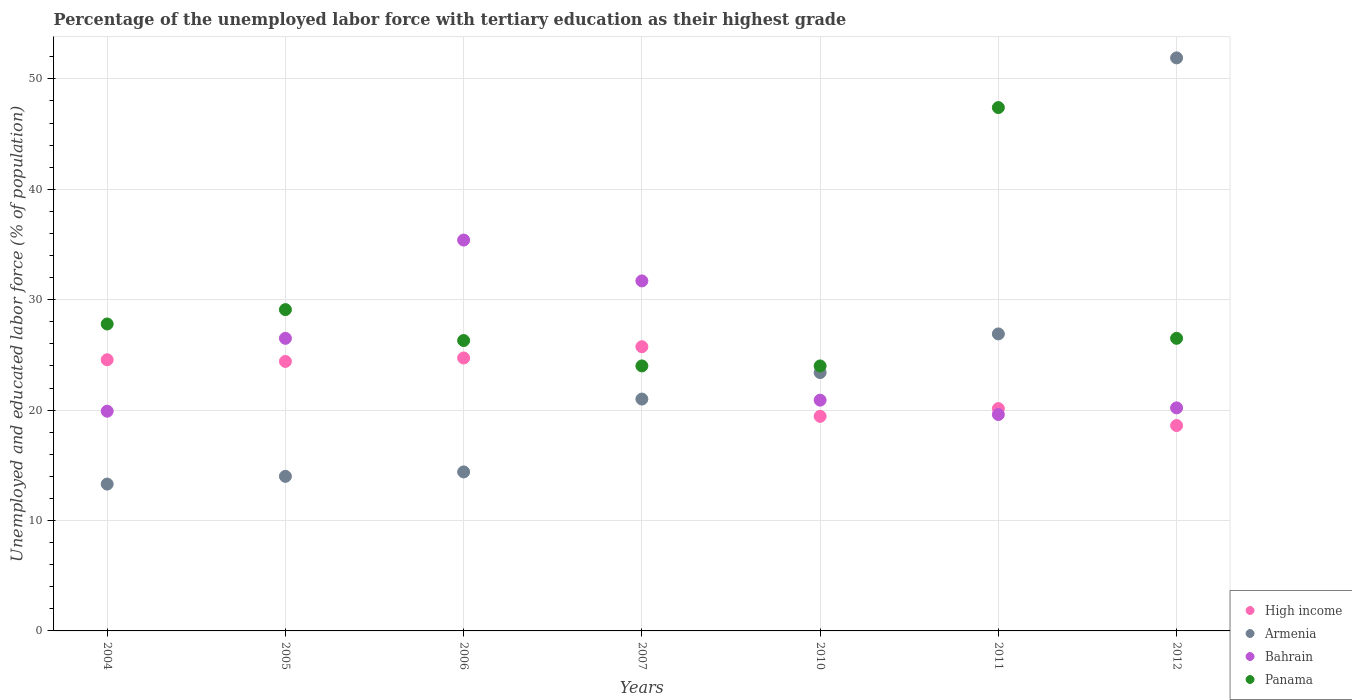How many different coloured dotlines are there?
Provide a succinct answer. 4. What is the percentage of the unemployed labor force with tertiary education in Armenia in 2006?
Keep it short and to the point. 14.4. Across all years, what is the maximum percentage of the unemployed labor force with tertiary education in High income?
Provide a succinct answer. 25.74. Across all years, what is the minimum percentage of the unemployed labor force with tertiary education in Armenia?
Keep it short and to the point. 13.3. In which year was the percentage of the unemployed labor force with tertiary education in High income maximum?
Your response must be concise. 2007. In which year was the percentage of the unemployed labor force with tertiary education in Armenia minimum?
Offer a very short reply. 2004. What is the total percentage of the unemployed labor force with tertiary education in Panama in the graph?
Give a very brief answer. 205.1. What is the difference between the percentage of the unemployed labor force with tertiary education in Armenia in 2004 and that in 2007?
Give a very brief answer. -7.7. What is the difference between the percentage of the unemployed labor force with tertiary education in Armenia in 2007 and the percentage of the unemployed labor force with tertiary education in Panama in 2010?
Give a very brief answer. -3. What is the average percentage of the unemployed labor force with tertiary education in Panama per year?
Offer a very short reply. 29.3. In the year 2005, what is the difference between the percentage of the unemployed labor force with tertiary education in Bahrain and percentage of the unemployed labor force with tertiary education in Panama?
Make the answer very short. -2.6. In how many years, is the percentage of the unemployed labor force with tertiary education in Panama greater than 16 %?
Keep it short and to the point. 7. What is the ratio of the percentage of the unemployed labor force with tertiary education in Panama in 2005 to that in 2012?
Make the answer very short. 1.1. Is the difference between the percentage of the unemployed labor force with tertiary education in Bahrain in 2005 and 2010 greater than the difference between the percentage of the unemployed labor force with tertiary education in Panama in 2005 and 2010?
Make the answer very short. Yes. What is the difference between the highest and the second highest percentage of the unemployed labor force with tertiary education in High income?
Ensure brevity in your answer.  1.02. What is the difference between the highest and the lowest percentage of the unemployed labor force with tertiary education in High income?
Make the answer very short. 7.14. Is the sum of the percentage of the unemployed labor force with tertiary education in High income in 2006 and 2011 greater than the maximum percentage of the unemployed labor force with tertiary education in Armenia across all years?
Your answer should be compact. No. Is it the case that in every year, the sum of the percentage of the unemployed labor force with tertiary education in Panama and percentage of the unemployed labor force with tertiary education in Bahrain  is greater than the percentage of the unemployed labor force with tertiary education in Armenia?
Offer a terse response. No. How many dotlines are there?
Your answer should be very brief. 4. How many years are there in the graph?
Make the answer very short. 7. What is the difference between two consecutive major ticks on the Y-axis?
Provide a succinct answer. 10. Are the values on the major ticks of Y-axis written in scientific E-notation?
Provide a succinct answer. No. Does the graph contain any zero values?
Provide a short and direct response. No. Does the graph contain grids?
Keep it short and to the point. Yes. What is the title of the graph?
Give a very brief answer. Percentage of the unemployed labor force with tertiary education as their highest grade. What is the label or title of the Y-axis?
Your response must be concise. Unemployed and educated labor force (% of population). What is the Unemployed and educated labor force (% of population) of High income in 2004?
Offer a terse response. 24.56. What is the Unemployed and educated labor force (% of population) in Armenia in 2004?
Your response must be concise. 13.3. What is the Unemployed and educated labor force (% of population) in Bahrain in 2004?
Keep it short and to the point. 19.9. What is the Unemployed and educated labor force (% of population) in Panama in 2004?
Your answer should be very brief. 27.8. What is the Unemployed and educated labor force (% of population) in High income in 2005?
Offer a very short reply. 24.41. What is the Unemployed and educated labor force (% of population) of Armenia in 2005?
Your answer should be compact. 14. What is the Unemployed and educated labor force (% of population) in Panama in 2005?
Offer a very short reply. 29.1. What is the Unemployed and educated labor force (% of population) in High income in 2006?
Your response must be concise. 24.72. What is the Unemployed and educated labor force (% of population) of Armenia in 2006?
Make the answer very short. 14.4. What is the Unemployed and educated labor force (% of population) in Bahrain in 2006?
Offer a terse response. 35.4. What is the Unemployed and educated labor force (% of population) of Panama in 2006?
Provide a succinct answer. 26.3. What is the Unemployed and educated labor force (% of population) of High income in 2007?
Offer a very short reply. 25.74. What is the Unemployed and educated labor force (% of population) of Bahrain in 2007?
Your answer should be very brief. 31.7. What is the Unemployed and educated labor force (% of population) in Panama in 2007?
Give a very brief answer. 24. What is the Unemployed and educated labor force (% of population) of High income in 2010?
Give a very brief answer. 19.44. What is the Unemployed and educated labor force (% of population) in Armenia in 2010?
Your answer should be very brief. 23.4. What is the Unemployed and educated labor force (% of population) in Bahrain in 2010?
Ensure brevity in your answer.  20.9. What is the Unemployed and educated labor force (% of population) in Panama in 2010?
Provide a short and direct response. 24. What is the Unemployed and educated labor force (% of population) in High income in 2011?
Provide a short and direct response. 20.14. What is the Unemployed and educated labor force (% of population) of Armenia in 2011?
Your answer should be compact. 26.9. What is the Unemployed and educated labor force (% of population) of Bahrain in 2011?
Keep it short and to the point. 19.6. What is the Unemployed and educated labor force (% of population) in Panama in 2011?
Give a very brief answer. 47.4. What is the Unemployed and educated labor force (% of population) of High income in 2012?
Keep it short and to the point. 18.6. What is the Unemployed and educated labor force (% of population) of Armenia in 2012?
Offer a very short reply. 51.9. What is the Unemployed and educated labor force (% of population) in Bahrain in 2012?
Your answer should be compact. 20.2. Across all years, what is the maximum Unemployed and educated labor force (% of population) in High income?
Offer a very short reply. 25.74. Across all years, what is the maximum Unemployed and educated labor force (% of population) of Armenia?
Keep it short and to the point. 51.9. Across all years, what is the maximum Unemployed and educated labor force (% of population) in Bahrain?
Your response must be concise. 35.4. Across all years, what is the maximum Unemployed and educated labor force (% of population) in Panama?
Offer a very short reply. 47.4. Across all years, what is the minimum Unemployed and educated labor force (% of population) of High income?
Provide a short and direct response. 18.6. Across all years, what is the minimum Unemployed and educated labor force (% of population) in Armenia?
Ensure brevity in your answer.  13.3. Across all years, what is the minimum Unemployed and educated labor force (% of population) of Bahrain?
Provide a succinct answer. 19.6. Across all years, what is the minimum Unemployed and educated labor force (% of population) in Panama?
Provide a short and direct response. 24. What is the total Unemployed and educated labor force (% of population) of High income in the graph?
Offer a terse response. 157.6. What is the total Unemployed and educated labor force (% of population) in Armenia in the graph?
Provide a short and direct response. 164.9. What is the total Unemployed and educated labor force (% of population) of Bahrain in the graph?
Your answer should be compact. 174.2. What is the total Unemployed and educated labor force (% of population) of Panama in the graph?
Offer a very short reply. 205.1. What is the difference between the Unemployed and educated labor force (% of population) in High income in 2004 and that in 2005?
Keep it short and to the point. 0.15. What is the difference between the Unemployed and educated labor force (% of population) in High income in 2004 and that in 2006?
Keep it short and to the point. -0.16. What is the difference between the Unemployed and educated labor force (% of population) in Bahrain in 2004 and that in 2006?
Make the answer very short. -15.5. What is the difference between the Unemployed and educated labor force (% of population) in High income in 2004 and that in 2007?
Provide a succinct answer. -1.18. What is the difference between the Unemployed and educated labor force (% of population) of Armenia in 2004 and that in 2007?
Offer a terse response. -7.7. What is the difference between the Unemployed and educated labor force (% of population) in Bahrain in 2004 and that in 2007?
Ensure brevity in your answer.  -11.8. What is the difference between the Unemployed and educated labor force (% of population) of High income in 2004 and that in 2010?
Your response must be concise. 5.12. What is the difference between the Unemployed and educated labor force (% of population) in Armenia in 2004 and that in 2010?
Your response must be concise. -10.1. What is the difference between the Unemployed and educated labor force (% of population) in Bahrain in 2004 and that in 2010?
Your answer should be compact. -1. What is the difference between the Unemployed and educated labor force (% of population) of High income in 2004 and that in 2011?
Provide a short and direct response. 4.42. What is the difference between the Unemployed and educated labor force (% of population) in Armenia in 2004 and that in 2011?
Offer a very short reply. -13.6. What is the difference between the Unemployed and educated labor force (% of population) of Panama in 2004 and that in 2011?
Your answer should be compact. -19.6. What is the difference between the Unemployed and educated labor force (% of population) in High income in 2004 and that in 2012?
Offer a terse response. 5.96. What is the difference between the Unemployed and educated labor force (% of population) in Armenia in 2004 and that in 2012?
Make the answer very short. -38.6. What is the difference between the Unemployed and educated labor force (% of population) of Bahrain in 2004 and that in 2012?
Your answer should be compact. -0.3. What is the difference between the Unemployed and educated labor force (% of population) of High income in 2005 and that in 2006?
Ensure brevity in your answer.  -0.31. What is the difference between the Unemployed and educated labor force (% of population) of Armenia in 2005 and that in 2006?
Provide a short and direct response. -0.4. What is the difference between the Unemployed and educated labor force (% of population) in Bahrain in 2005 and that in 2006?
Offer a terse response. -8.9. What is the difference between the Unemployed and educated labor force (% of population) of Panama in 2005 and that in 2006?
Give a very brief answer. 2.8. What is the difference between the Unemployed and educated labor force (% of population) of High income in 2005 and that in 2007?
Offer a very short reply. -1.33. What is the difference between the Unemployed and educated labor force (% of population) of Armenia in 2005 and that in 2007?
Ensure brevity in your answer.  -7. What is the difference between the Unemployed and educated labor force (% of population) of High income in 2005 and that in 2010?
Keep it short and to the point. 4.97. What is the difference between the Unemployed and educated labor force (% of population) in Armenia in 2005 and that in 2010?
Give a very brief answer. -9.4. What is the difference between the Unemployed and educated labor force (% of population) in High income in 2005 and that in 2011?
Keep it short and to the point. 4.27. What is the difference between the Unemployed and educated labor force (% of population) of Armenia in 2005 and that in 2011?
Ensure brevity in your answer.  -12.9. What is the difference between the Unemployed and educated labor force (% of population) in Bahrain in 2005 and that in 2011?
Ensure brevity in your answer.  6.9. What is the difference between the Unemployed and educated labor force (% of population) in Panama in 2005 and that in 2011?
Ensure brevity in your answer.  -18.3. What is the difference between the Unemployed and educated labor force (% of population) of High income in 2005 and that in 2012?
Offer a terse response. 5.81. What is the difference between the Unemployed and educated labor force (% of population) of Armenia in 2005 and that in 2012?
Give a very brief answer. -37.9. What is the difference between the Unemployed and educated labor force (% of population) of Panama in 2005 and that in 2012?
Make the answer very short. 2.6. What is the difference between the Unemployed and educated labor force (% of population) in High income in 2006 and that in 2007?
Ensure brevity in your answer.  -1.02. What is the difference between the Unemployed and educated labor force (% of population) in Armenia in 2006 and that in 2007?
Offer a very short reply. -6.6. What is the difference between the Unemployed and educated labor force (% of population) of Bahrain in 2006 and that in 2007?
Provide a short and direct response. 3.7. What is the difference between the Unemployed and educated labor force (% of population) in Panama in 2006 and that in 2007?
Give a very brief answer. 2.3. What is the difference between the Unemployed and educated labor force (% of population) of High income in 2006 and that in 2010?
Provide a short and direct response. 5.29. What is the difference between the Unemployed and educated labor force (% of population) in Armenia in 2006 and that in 2010?
Give a very brief answer. -9. What is the difference between the Unemployed and educated labor force (% of population) in Panama in 2006 and that in 2010?
Your response must be concise. 2.3. What is the difference between the Unemployed and educated labor force (% of population) of High income in 2006 and that in 2011?
Offer a terse response. 4.58. What is the difference between the Unemployed and educated labor force (% of population) of Armenia in 2006 and that in 2011?
Your answer should be very brief. -12.5. What is the difference between the Unemployed and educated labor force (% of population) in Panama in 2006 and that in 2011?
Provide a short and direct response. -21.1. What is the difference between the Unemployed and educated labor force (% of population) of High income in 2006 and that in 2012?
Offer a terse response. 6.12. What is the difference between the Unemployed and educated labor force (% of population) in Armenia in 2006 and that in 2012?
Your answer should be compact. -37.5. What is the difference between the Unemployed and educated labor force (% of population) in High income in 2007 and that in 2010?
Your answer should be compact. 6.3. What is the difference between the Unemployed and educated labor force (% of population) in Armenia in 2007 and that in 2010?
Your answer should be very brief. -2.4. What is the difference between the Unemployed and educated labor force (% of population) in Bahrain in 2007 and that in 2010?
Your response must be concise. 10.8. What is the difference between the Unemployed and educated labor force (% of population) of Panama in 2007 and that in 2010?
Offer a very short reply. 0. What is the difference between the Unemployed and educated labor force (% of population) in High income in 2007 and that in 2011?
Make the answer very short. 5.6. What is the difference between the Unemployed and educated labor force (% of population) of Panama in 2007 and that in 2011?
Offer a terse response. -23.4. What is the difference between the Unemployed and educated labor force (% of population) of High income in 2007 and that in 2012?
Give a very brief answer. 7.14. What is the difference between the Unemployed and educated labor force (% of population) in Armenia in 2007 and that in 2012?
Your answer should be very brief. -30.9. What is the difference between the Unemployed and educated labor force (% of population) of High income in 2010 and that in 2011?
Ensure brevity in your answer.  -0.7. What is the difference between the Unemployed and educated labor force (% of population) of Armenia in 2010 and that in 2011?
Your response must be concise. -3.5. What is the difference between the Unemployed and educated labor force (% of population) in Panama in 2010 and that in 2011?
Your response must be concise. -23.4. What is the difference between the Unemployed and educated labor force (% of population) of High income in 2010 and that in 2012?
Your response must be concise. 0.83. What is the difference between the Unemployed and educated labor force (% of population) in Armenia in 2010 and that in 2012?
Offer a very short reply. -28.5. What is the difference between the Unemployed and educated labor force (% of population) in Panama in 2010 and that in 2012?
Your response must be concise. -2.5. What is the difference between the Unemployed and educated labor force (% of population) in High income in 2011 and that in 2012?
Your response must be concise. 1.54. What is the difference between the Unemployed and educated labor force (% of population) in Armenia in 2011 and that in 2012?
Make the answer very short. -25. What is the difference between the Unemployed and educated labor force (% of population) in Bahrain in 2011 and that in 2012?
Your response must be concise. -0.6. What is the difference between the Unemployed and educated labor force (% of population) of Panama in 2011 and that in 2012?
Offer a very short reply. 20.9. What is the difference between the Unemployed and educated labor force (% of population) in High income in 2004 and the Unemployed and educated labor force (% of population) in Armenia in 2005?
Offer a terse response. 10.56. What is the difference between the Unemployed and educated labor force (% of population) in High income in 2004 and the Unemployed and educated labor force (% of population) in Bahrain in 2005?
Your response must be concise. -1.94. What is the difference between the Unemployed and educated labor force (% of population) of High income in 2004 and the Unemployed and educated labor force (% of population) of Panama in 2005?
Make the answer very short. -4.54. What is the difference between the Unemployed and educated labor force (% of population) of Armenia in 2004 and the Unemployed and educated labor force (% of population) of Panama in 2005?
Provide a short and direct response. -15.8. What is the difference between the Unemployed and educated labor force (% of population) of High income in 2004 and the Unemployed and educated labor force (% of population) of Armenia in 2006?
Ensure brevity in your answer.  10.16. What is the difference between the Unemployed and educated labor force (% of population) in High income in 2004 and the Unemployed and educated labor force (% of population) in Bahrain in 2006?
Ensure brevity in your answer.  -10.84. What is the difference between the Unemployed and educated labor force (% of population) of High income in 2004 and the Unemployed and educated labor force (% of population) of Panama in 2006?
Your response must be concise. -1.74. What is the difference between the Unemployed and educated labor force (% of population) in Armenia in 2004 and the Unemployed and educated labor force (% of population) in Bahrain in 2006?
Provide a short and direct response. -22.1. What is the difference between the Unemployed and educated labor force (% of population) in Armenia in 2004 and the Unemployed and educated labor force (% of population) in Panama in 2006?
Offer a terse response. -13. What is the difference between the Unemployed and educated labor force (% of population) in High income in 2004 and the Unemployed and educated labor force (% of population) in Armenia in 2007?
Your answer should be very brief. 3.56. What is the difference between the Unemployed and educated labor force (% of population) of High income in 2004 and the Unemployed and educated labor force (% of population) of Bahrain in 2007?
Offer a terse response. -7.14. What is the difference between the Unemployed and educated labor force (% of population) in High income in 2004 and the Unemployed and educated labor force (% of population) in Panama in 2007?
Give a very brief answer. 0.56. What is the difference between the Unemployed and educated labor force (% of population) in Armenia in 2004 and the Unemployed and educated labor force (% of population) in Bahrain in 2007?
Your answer should be compact. -18.4. What is the difference between the Unemployed and educated labor force (% of population) in Armenia in 2004 and the Unemployed and educated labor force (% of population) in Panama in 2007?
Make the answer very short. -10.7. What is the difference between the Unemployed and educated labor force (% of population) in Bahrain in 2004 and the Unemployed and educated labor force (% of population) in Panama in 2007?
Provide a short and direct response. -4.1. What is the difference between the Unemployed and educated labor force (% of population) of High income in 2004 and the Unemployed and educated labor force (% of population) of Armenia in 2010?
Your response must be concise. 1.16. What is the difference between the Unemployed and educated labor force (% of population) of High income in 2004 and the Unemployed and educated labor force (% of population) of Bahrain in 2010?
Give a very brief answer. 3.66. What is the difference between the Unemployed and educated labor force (% of population) of High income in 2004 and the Unemployed and educated labor force (% of population) of Panama in 2010?
Provide a succinct answer. 0.56. What is the difference between the Unemployed and educated labor force (% of population) in Armenia in 2004 and the Unemployed and educated labor force (% of population) in Bahrain in 2010?
Offer a very short reply. -7.6. What is the difference between the Unemployed and educated labor force (% of population) of Armenia in 2004 and the Unemployed and educated labor force (% of population) of Panama in 2010?
Your response must be concise. -10.7. What is the difference between the Unemployed and educated labor force (% of population) in Bahrain in 2004 and the Unemployed and educated labor force (% of population) in Panama in 2010?
Your answer should be very brief. -4.1. What is the difference between the Unemployed and educated labor force (% of population) in High income in 2004 and the Unemployed and educated labor force (% of population) in Armenia in 2011?
Ensure brevity in your answer.  -2.34. What is the difference between the Unemployed and educated labor force (% of population) of High income in 2004 and the Unemployed and educated labor force (% of population) of Bahrain in 2011?
Your response must be concise. 4.96. What is the difference between the Unemployed and educated labor force (% of population) in High income in 2004 and the Unemployed and educated labor force (% of population) in Panama in 2011?
Your answer should be very brief. -22.84. What is the difference between the Unemployed and educated labor force (% of population) in Armenia in 2004 and the Unemployed and educated labor force (% of population) in Bahrain in 2011?
Your response must be concise. -6.3. What is the difference between the Unemployed and educated labor force (% of population) of Armenia in 2004 and the Unemployed and educated labor force (% of population) of Panama in 2011?
Make the answer very short. -34.1. What is the difference between the Unemployed and educated labor force (% of population) in Bahrain in 2004 and the Unemployed and educated labor force (% of population) in Panama in 2011?
Keep it short and to the point. -27.5. What is the difference between the Unemployed and educated labor force (% of population) in High income in 2004 and the Unemployed and educated labor force (% of population) in Armenia in 2012?
Make the answer very short. -27.34. What is the difference between the Unemployed and educated labor force (% of population) of High income in 2004 and the Unemployed and educated labor force (% of population) of Bahrain in 2012?
Keep it short and to the point. 4.36. What is the difference between the Unemployed and educated labor force (% of population) in High income in 2004 and the Unemployed and educated labor force (% of population) in Panama in 2012?
Give a very brief answer. -1.94. What is the difference between the Unemployed and educated labor force (% of population) of High income in 2005 and the Unemployed and educated labor force (% of population) of Armenia in 2006?
Offer a very short reply. 10.01. What is the difference between the Unemployed and educated labor force (% of population) in High income in 2005 and the Unemployed and educated labor force (% of population) in Bahrain in 2006?
Provide a short and direct response. -10.99. What is the difference between the Unemployed and educated labor force (% of population) in High income in 2005 and the Unemployed and educated labor force (% of population) in Panama in 2006?
Keep it short and to the point. -1.89. What is the difference between the Unemployed and educated labor force (% of population) of Armenia in 2005 and the Unemployed and educated labor force (% of population) of Bahrain in 2006?
Offer a terse response. -21.4. What is the difference between the Unemployed and educated labor force (% of population) in Armenia in 2005 and the Unemployed and educated labor force (% of population) in Panama in 2006?
Offer a very short reply. -12.3. What is the difference between the Unemployed and educated labor force (% of population) in Bahrain in 2005 and the Unemployed and educated labor force (% of population) in Panama in 2006?
Your answer should be very brief. 0.2. What is the difference between the Unemployed and educated labor force (% of population) in High income in 2005 and the Unemployed and educated labor force (% of population) in Armenia in 2007?
Make the answer very short. 3.41. What is the difference between the Unemployed and educated labor force (% of population) of High income in 2005 and the Unemployed and educated labor force (% of population) of Bahrain in 2007?
Provide a succinct answer. -7.29. What is the difference between the Unemployed and educated labor force (% of population) of High income in 2005 and the Unemployed and educated labor force (% of population) of Panama in 2007?
Your response must be concise. 0.41. What is the difference between the Unemployed and educated labor force (% of population) in Armenia in 2005 and the Unemployed and educated labor force (% of population) in Bahrain in 2007?
Provide a succinct answer. -17.7. What is the difference between the Unemployed and educated labor force (% of population) in High income in 2005 and the Unemployed and educated labor force (% of population) in Armenia in 2010?
Make the answer very short. 1.01. What is the difference between the Unemployed and educated labor force (% of population) in High income in 2005 and the Unemployed and educated labor force (% of population) in Bahrain in 2010?
Provide a succinct answer. 3.51. What is the difference between the Unemployed and educated labor force (% of population) in High income in 2005 and the Unemployed and educated labor force (% of population) in Panama in 2010?
Keep it short and to the point. 0.41. What is the difference between the Unemployed and educated labor force (% of population) in Armenia in 2005 and the Unemployed and educated labor force (% of population) in Bahrain in 2010?
Give a very brief answer. -6.9. What is the difference between the Unemployed and educated labor force (% of population) in Armenia in 2005 and the Unemployed and educated labor force (% of population) in Panama in 2010?
Offer a very short reply. -10. What is the difference between the Unemployed and educated labor force (% of population) in High income in 2005 and the Unemployed and educated labor force (% of population) in Armenia in 2011?
Keep it short and to the point. -2.49. What is the difference between the Unemployed and educated labor force (% of population) of High income in 2005 and the Unemployed and educated labor force (% of population) of Bahrain in 2011?
Offer a terse response. 4.81. What is the difference between the Unemployed and educated labor force (% of population) in High income in 2005 and the Unemployed and educated labor force (% of population) in Panama in 2011?
Keep it short and to the point. -22.99. What is the difference between the Unemployed and educated labor force (% of population) in Armenia in 2005 and the Unemployed and educated labor force (% of population) in Bahrain in 2011?
Provide a short and direct response. -5.6. What is the difference between the Unemployed and educated labor force (% of population) of Armenia in 2005 and the Unemployed and educated labor force (% of population) of Panama in 2011?
Give a very brief answer. -33.4. What is the difference between the Unemployed and educated labor force (% of population) in Bahrain in 2005 and the Unemployed and educated labor force (% of population) in Panama in 2011?
Provide a succinct answer. -20.9. What is the difference between the Unemployed and educated labor force (% of population) of High income in 2005 and the Unemployed and educated labor force (% of population) of Armenia in 2012?
Keep it short and to the point. -27.49. What is the difference between the Unemployed and educated labor force (% of population) in High income in 2005 and the Unemployed and educated labor force (% of population) in Bahrain in 2012?
Make the answer very short. 4.21. What is the difference between the Unemployed and educated labor force (% of population) in High income in 2005 and the Unemployed and educated labor force (% of population) in Panama in 2012?
Make the answer very short. -2.09. What is the difference between the Unemployed and educated labor force (% of population) of High income in 2006 and the Unemployed and educated labor force (% of population) of Armenia in 2007?
Keep it short and to the point. 3.72. What is the difference between the Unemployed and educated labor force (% of population) of High income in 2006 and the Unemployed and educated labor force (% of population) of Bahrain in 2007?
Offer a terse response. -6.98. What is the difference between the Unemployed and educated labor force (% of population) of High income in 2006 and the Unemployed and educated labor force (% of population) of Panama in 2007?
Give a very brief answer. 0.72. What is the difference between the Unemployed and educated labor force (% of population) in Armenia in 2006 and the Unemployed and educated labor force (% of population) in Bahrain in 2007?
Make the answer very short. -17.3. What is the difference between the Unemployed and educated labor force (% of population) of Armenia in 2006 and the Unemployed and educated labor force (% of population) of Panama in 2007?
Keep it short and to the point. -9.6. What is the difference between the Unemployed and educated labor force (% of population) in Bahrain in 2006 and the Unemployed and educated labor force (% of population) in Panama in 2007?
Your answer should be compact. 11.4. What is the difference between the Unemployed and educated labor force (% of population) in High income in 2006 and the Unemployed and educated labor force (% of population) in Armenia in 2010?
Ensure brevity in your answer.  1.32. What is the difference between the Unemployed and educated labor force (% of population) in High income in 2006 and the Unemployed and educated labor force (% of population) in Bahrain in 2010?
Your answer should be compact. 3.82. What is the difference between the Unemployed and educated labor force (% of population) of High income in 2006 and the Unemployed and educated labor force (% of population) of Panama in 2010?
Offer a very short reply. 0.72. What is the difference between the Unemployed and educated labor force (% of population) of Armenia in 2006 and the Unemployed and educated labor force (% of population) of Bahrain in 2010?
Provide a succinct answer. -6.5. What is the difference between the Unemployed and educated labor force (% of population) in High income in 2006 and the Unemployed and educated labor force (% of population) in Armenia in 2011?
Provide a short and direct response. -2.18. What is the difference between the Unemployed and educated labor force (% of population) in High income in 2006 and the Unemployed and educated labor force (% of population) in Bahrain in 2011?
Provide a succinct answer. 5.12. What is the difference between the Unemployed and educated labor force (% of population) of High income in 2006 and the Unemployed and educated labor force (% of population) of Panama in 2011?
Your response must be concise. -22.68. What is the difference between the Unemployed and educated labor force (% of population) of Armenia in 2006 and the Unemployed and educated labor force (% of population) of Panama in 2011?
Give a very brief answer. -33. What is the difference between the Unemployed and educated labor force (% of population) in Bahrain in 2006 and the Unemployed and educated labor force (% of population) in Panama in 2011?
Provide a short and direct response. -12. What is the difference between the Unemployed and educated labor force (% of population) of High income in 2006 and the Unemployed and educated labor force (% of population) of Armenia in 2012?
Your response must be concise. -27.18. What is the difference between the Unemployed and educated labor force (% of population) of High income in 2006 and the Unemployed and educated labor force (% of population) of Bahrain in 2012?
Ensure brevity in your answer.  4.52. What is the difference between the Unemployed and educated labor force (% of population) of High income in 2006 and the Unemployed and educated labor force (% of population) of Panama in 2012?
Your answer should be very brief. -1.78. What is the difference between the Unemployed and educated labor force (% of population) of Armenia in 2006 and the Unemployed and educated labor force (% of population) of Bahrain in 2012?
Provide a succinct answer. -5.8. What is the difference between the Unemployed and educated labor force (% of population) of High income in 2007 and the Unemployed and educated labor force (% of population) of Armenia in 2010?
Make the answer very short. 2.34. What is the difference between the Unemployed and educated labor force (% of population) of High income in 2007 and the Unemployed and educated labor force (% of population) of Bahrain in 2010?
Give a very brief answer. 4.84. What is the difference between the Unemployed and educated labor force (% of population) in High income in 2007 and the Unemployed and educated labor force (% of population) in Panama in 2010?
Offer a very short reply. 1.74. What is the difference between the Unemployed and educated labor force (% of population) of Armenia in 2007 and the Unemployed and educated labor force (% of population) of Panama in 2010?
Your response must be concise. -3. What is the difference between the Unemployed and educated labor force (% of population) in High income in 2007 and the Unemployed and educated labor force (% of population) in Armenia in 2011?
Your answer should be compact. -1.16. What is the difference between the Unemployed and educated labor force (% of population) of High income in 2007 and the Unemployed and educated labor force (% of population) of Bahrain in 2011?
Offer a terse response. 6.14. What is the difference between the Unemployed and educated labor force (% of population) of High income in 2007 and the Unemployed and educated labor force (% of population) of Panama in 2011?
Give a very brief answer. -21.66. What is the difference between the Unemployed and educated labor force (% of population) in Armenia in 2007 and the Unemployed and educated labor force (% of population) in Bahrain in 2011?
Ensure brevity in your answer.  1.4. What is the difference between the Unemployed and educated labor force (% of population) in Armenia in 2007 and the Unemployed and educated labor force (% of population) in Panama in 2011?
Provide a succinct answer. -26.4. What is the difference between the Unemployed and educated labor force (% of population) in Bahrain in 2007 and the Unemployed and educated labor force (% of population) in Panama in 2011?
Your response must be concise. -15.7. What is the difference between the Unemployed and educated labor force (% of population) of High income in 2007 and the Unemployed and educated labor force (% of population) of Armenia in 2012?
Offer a terse response. -26.16. What is the difference between the Unemployed and educated labor force (% of population) in High income in 2007 and the Unemployed and educated labor force (% of population) in Bahrain in 2012?
Keep it short and to the point. 5.54. What is the difference between the Unemployed and educated labor force (% of population) of High income in 2007 and the Unemployed and educated labor force (% of population) of Panama in 2012?
Keep it short and to the point. -0.76. What is the difference between the Unemployed and educated labor force (% of population) in Armenia in 2007 and the Unemployed and educated labor force (% of population) in Panama in 2012?
Give a very brief answer. -5.5. What is the difference between the Unemployed and educated labor force (% of population) in Bahrain in 2007 and the Unemployed and educated labor force (% of population) in Panama in 2012?
Give a very brief answer. 5.2. What is the difference between the Unemployed and educated labor force (% of population) of High income in 2010 and the Unemployed and educated labor force (% of population) of Armenia in 2011?
Offer a terse response. -7.46. What is the difference between the Unemployed and educated labor force (% of population) in High income in 2010 and the Unemployed and educated labor force (% of population) in Bahrain in 2011?
Offer a very short reply. -0.16. What is the difference between the Unemployed and educated labor force (% of population) in High income in 2010 and the Unemployed and educated labor force (% of population) in Panama in 2011?
Your answer should be very brief. -27.96. What is the difference between the Unemployed and educated labor force (% of population) in Armenia in 2010 and the Unemployed and educated labor force (% of population) in Panama in 2011?
Your response must be concise. -24. What is the difference between the Unemployed and educated labor force (% of population) in Bahrain in 2010 and the Unemployed and educated labor force (% of population) in Panama in 2011?
Your answer should be compact. -26.5. What is the difference between the Unemployed and educated labor force (% of population) in High income in 2010 and the Unemployed and educated labor force (% of population) in Armenia in 2012?
Offer a terse response. -32.46. What is the difference between the Unemployed and educated labor force (% of population) of High income in 2010 and the Unemployed and educated labor force (% of population) of Bahrain in 2012?
Your response must be concise. -0.76. What is the difference between the Unemployed and educated labor force (% of population) of High income in 2010 and the Unemployed and educated labor force (% of population) of Panama in 2012?
Offer a terse response. -7.06. What is the difference between the Unemployed and educated labor force (% of population) in Armenia in 2010 and the Unemployed and educated labor force (% of population) in Bahrain in 2012?
Your response must be concise. 3.2. What is the difference between the Unemployed and educated labor force (% of population) of Armenia in 2010 and the Unemployed and educated labor force (% of population) of Panama in 2012?
Ensure brevity in your answer.  -3.1. What is the difference between the Unemployed and educated labor force (% of population) of High income in 2011 and the Unemployed and educated labor force (% of population) of Armenia in 2012?
Offer a terse response. -31.76. What is the difference between the Unemployed and educated labor force (% of population) in High income in 2011 and the Unemployed and educated labor force (% of population) in Bahrain in 2012?
Offer a terse response. -0.06. What is the difference between the Unemployed and educated labor force (% of population) of High income in 2011 and the Unemployed and educated labor force (% of population) of Panama in 2012?
Keep it short and to the point. -6.36. What is the difference between the Unemployed and educated labor force (% of population) of Armenia in 2011 and the Unemployed and educated labor force (% of population) of Panama in 2012?
Your answer should be compact. 0.4. What is the difference between the Unemployed and educated labor force (% of population) in Bahrain in 2011 and the Unemployed and educated labor force (% of population) in Panama in 2012?
Make the answer very short. -6.9. What is the average Unemployed and educated labor force (% of population) of High income per year?
Offer a very short reply. 22.51. What is the average Unemployed and educated labor force (% of population) in Armenia per year?
Make the answer very short. 23.56. What is the average Unemployed and educated labor force (% of population) in Bahrain per year?
Ensure brevity in your answer.  24.89. What is the average Unemployed and educated labor force (% of population) in Panama per year?
Your answer should be very brief. 29.3. In the year 2004, what is the difference between the Unemployed and educated labor force (% of population) in High income and Unemployed and educated labor force (% of population) in Armenia?
Provide a succinct answer. 11.26. In the year 2004, what is the difference between the Unemployed and educated labor force (% of population) of High income and Unemployed and educated labor force (% of population) of Bahrain?
Give a very brief answer. 4.66. In the year 2004, what is the difference between the Unemployed and educated labor force (% of population) in High income and Unemployed and educated labor force (% of population) in Panama?
Ensure brevity in your answer.  -3.24. In the year 2004, what is the difference between the Unemployed and educated labor force (% of population) of Armenia and Unemployed and educated labor force (% of population) of Bahrain?
Give a very brief answer. -6.6. In the year 2004, what is the difference between the Unemployed and educated labor force (% of population) in Bahrain and Unemployed and educated labor force (% of population) in Panama?
Your answer should be very brief. -7.9. In the year 2005, what is the difference between the Unemployed and educated labor force (% of population) of High income and Unemployed and educated labor force (% of population) of Armenia?
Your response must be concise. 10.41. In the year 2005, what is the difference between the Unemployed and educated labor force (% of population) in High income and Unemployed and educated labor force (% of population) in Bahrain?
Give a very brief answer. -2.09. In the year 2005, what is the difference between the Unemployed and educated labor force (% of population) of High income and Unemployed and educated labor force (% of population) of Panama?
Give a very brief answer. -4.69. In the year 2005, what is the difference between the Unemployed and educated labor force (% of population) of Armenia and Unemployed and educated labor force (% of population) of Bahrain?
Your answer should be compact. -12.5. In the year 2005, what is the difference between the Unemployed and educated labor force (% of population) in Armenia and Unemployed and educated labor force (% of population) in Panama?
Offer a terse response. -15.1. In the year 2005, what is the difference between the Unemployed and educated labor force (% of population) of Bahrain and Unemployed and educated labor force (% of population) of Panama?
Make the answer very short. -2.6. In the year 2006, what is the difference between the Unemployed and educated labor force (% of population) of High income and Unemployed and educated labor force (% of population) of Armenia?
Provide a succinct answer. 10.32. In the year 2006, what is the difference between the Unemployed and educated labor force (% of population) in High income and Unemployed and educated labor force (% of population) in Bahrain?
Give a very brief answer. -10.68. In the year 2006, what is the difference between the Unemployed and educated labor force (% of population) in High income and Unemployed and educated labor force (% of population) in Panama?
Offer a very short reply. -1.58. In the year 2006, what is the difference between the Unemployed and educated labor force (% of population) of Armenia and Unemployed and educated labor force (% of population) of Panama?
Your response must be concise. -11.9. In the year 2006, what is the difference between the Unemployed and educated labor force (% of population) in Bahrain and Unemployed and educated labor force (% of population) in Panama?
Your answer should be very brief. 9.1. In the year 2007, what is the difference between the Unemployed and educated labor force (% of population) of High income and Unemployed and educated labor force (% of population) of Armenia?
Provide a short and direct response. 4.74. In the year 2007, what is the difference between the Unemployed and educated labor force (% of population) in High income and Unemployed and educated labor force (% of population) in Bahrain?
Keep it short and to the point. -5.96. In the year 2007, what is the difference between the Unemployed and educated labor force (% of population) in High income and Unemployed and educated labor force (% of population) in Panama?
Ensure brevity in your answer.  1.74. In the year 2007, what is the difference between the Unemployed and educated labor force (% of population) in Armenia and Unemployed and educated labor force (% of population) in Panama?
Your answer should be very brief. -3. In the year 2007, what is the difference between the Unemployed and educated labor force (% of population) of Bahrain and Unemployed and educated labor force (% of population) of Panama?
Offer a very short reply. 7.7. In the year 2010, what is the difference between the Unemployed and educated labor force (% of population) of High income and Unemployed and educated labor force (% of population) of Armenia?
Offer a very short reply. -3.96. In the year 2010, what is the difference between the Unemployed and educated labor force (% of population) in High income and Unemployed and educated labor force (% of population) in Bahrain?
Your answer should be compact. -1.46. In the year 2010, what is the difference between the Unemployed and educated labor force (% of population) in High income and Unemployed and educated labor force (% of population) in Panama?
Your answer should be compact. -4.56. In the year 2010, what is the difference between the Unemployed and educated labor force (% of population) of Armenia and Unemployed and educated labor force (% of population) of Bahrain?
Make the answer very short. 2.5. In the year 2011, what is the difference between the Unemployed and educated labor force (% of population) in High income and Unemployed and educated labor force (% of population) in Armenia?
Your response must be concise. -6.76. In the year 2011, what is the difference between the Unemployed and educated labor force (% of population) in High income and Unemployed and educated labor force (% of population) in Bahrain?
Provide a succinct answer. 0.54. In the year 2011, what is the difference between the Unemployed and educated labor force (% of population) of High income and Unemployed and educated labor force (% of population) of Panama?
Ensure brevity in your answer.  -27.26. In the year 2011, what is the difference between the Unemployed and educated labor force (% of population) in Armenia and Unemployed and educated labor force (% of population) in Bahrain?
Your answer should be very brief. 7.3. In the year 2011, what is the difference between the Unemployed and educated labor force (% of population) in Armenia and Unemployed and educated labor force (% of population) in Panama?
Your answer should be compact. -20.5. In the year 2011, what is the difference between the Unemployed and educated labor force (% of population) in Bahrain and Unemployed and educated labor force (% of population) in Panama?
Offer a terse response. -27.8. In the year 2012, what is the difference between the Unemployed and educated labor force (% of population) of High income and Unemployed and educated labor force (% of population) of Armenia?
Keep it short and to the point. -33.3. In the year 2012, what is the difference between the Unemployed and educated labor force (% of population) of High income and Unemployed and educated labor force (% of population) of Bahrain?
Offer a very short reply. -1.6. In the year 2012, what is the difference between the Unemployed and educated labor force (% of population) of High income and Unemployed and educated labor force (% of population) of Panama?
Offer a very short reply. -7.9. In the year 2012, what is the difference between the Unemployed and educated labor force (% of population) in Armenia and Unemployed and educated labor force (% of population) in Bahrain?
Offer a very short reply. 31.7. In the year 2012, what is the difference between the Unemployed and educated labor force (% of population) in Armenia and Unemployed and educated labor force (% of population) in Panama?
Make the answer very short. 25.4. What is the ratio of the Unemployed and educated labor force (% of population) in High income in 2004 to that in 2005?
Provide a short and direct response. 1.01. What is the ratio of the Unemployed and educated labor force (% of population) in Armenia in 2004 to that in 2005?
Keep it short and to the point. 0.95. What is the ratio of the Unemployed and educated labor force (% of population) in Bahrain in 2004 to that in 2005?
Offer a very short reply. 0.75. What is the ratio of the Unemployed and educated labor force (% of population) in Panama in 2004 to that in 2005?
Your answer should be compact. 0.96. What is the ratio of the Unemployed and educated labor force (% of population) in High income in 2004 to that in 2006?
Your answer should be very brief. 0.99. What is the ratio of the Unemployed and educated labor force (% of population) of Armenia in 2004 to that in 2006?
Your answer should be compact. 0.92. What is the ratio of the Unemployed and educated labor force (% of population) of Bahrain in 2004 to that in 2006?
Keep it short and to the point. 0.56. What is the ratio of the Unemployed and educated labor force (% of population) of Panama in 2004 to that in 2006?
Keep it short and to the point. 1.06. What is the ratio of the Unemployed and educated labor force (% of population) of High income in 2004 to that in 2007?
Your answer should be very brief. 0.95. What is the ratio of the Unemployed and educated labor force (% of population) of Armenia in 2004 to that in 2007?
Your answer should be very brief. 0.63. What is the ratio of the Unemployed and educated labor force (% of population) in Bahrain in 2004 to that in 2007?
Ensure brevity in your answer.  0.63. What is the ratio of the Unemployed and educated labor force (% of population) in Panama in 2004 to that in 2007?
Your response must be concise. 1.16. What is the ratio of the Unemployed and educated labor force (% of population) of High income in 2004 to that in 2010?
Make the answer very short. 1.26. What is the ratio of the Unemployed and educated labor force (% of population) of Armenia in 2004 to that in 2010?
Offer a terse response. 0.57. What is the ratio of the Unemployed and educated labor force (% of population) of Bahrain in 2004 to that in 2010?
Ensure brevity in your answer.  0.95. What is the ratio of the Unemployed and educated labor force (% of population) of Panama in 2004 to that in 2010?
Give a very brief answer. 1.16. What is the ratio of the Unemployed and educated labor force (% of population) in High income in 2004 to that in 2011?
Offer a terse response. 1.22. What is the ratio of the Unemployed and educated labor force (% of population) in Armenia in 2004 to that in 2011?
Your response must be concise. 0.49. What is the ratio of the Unemployed and educated labor force (% of population) of Bahrain in 2004 to that in 2011?
Offer a terse response. 1.02. What is the ratio of the Unemployed and educated labor force (% of population) of Panama in 2004 to that in 2011?
Provide a short and direct response. 0.59. What is the ratio of the Unemployed and educated labor force (% of population) in High income in 2004 to that in 2012?
Keep it short and to the point. 1.32. What is the ratio of the Unemployed and educated labor force (% of population) of Armenia in 2004 to that in 2012?
Give a very brief answer. 0.26. What is the ratio of the Unemployed and educated labor force (% of population) of Bahrain in 2004 to that in 2012?
Offer a very short reply. 0.99. What is the ratio of the Unemployed and educated labor force (% of population) of Panama in 2004 to that in 2012?
Make the answer very short. 1.05. What is the ratio of the Unemployed and educated labor force (% of population) of High income in 2005 to that in 2006?
Offer a terse response. 0.99. What is the ratio of the Unemployed and educated labor force (% of population) of Armenia in 2005 to that in 2006?
Offer a very short reply. 0.97. What is the ratio of the Unemployed and educated labor force (% of population) in Bahrain in 2005 to that in 2006?
Provide a succinct answer. 0.75. What is the ratio of the Unemployed and educated labor force (% of population) of Panama in 2005 to that in 2006?
Offer a very short reply. 1.11. What is the ratio of the Unemployed and educated labor force (% of population) in High income in 2005 to that in 2007?
Ensure brevity in your answer.  0.95. What is the ratio of the Unemployed and educated labor force (% of population) of Armenia in 2005 to that in 2007?
Offer a very short reply. 0.67. What is the ratio of the Unemployed and educated labor force (% of population) of Bahrain in 2005 to that in 2007?
Keep it short and to the point. 0.84. What is the ratio of the Unemployed and educated labor force (% of population) of Panama in 2005 to that in 2007?
Your response must be concise. 1.21. What is the ratio of the Unemployed and educated labor force (% of population) of High income in 2005 to that in 2010?
Offer a terse response. 1.26. What is the ratio of the Unemployed and educated labor force (% of population) of Armenia in 2005 to that in 2010?
Your answer should be very brief. 0.6. What is the ratio of the Unemployed and educated labor force (% of population) in Bahrain in 2005 to that in 2010?
Your answer should be very brief. 1.27. What is the ratio of the Unemployed and educated labor force (% of population) in Panama in 2005 to that in 2010?
Give a very brief answer. 1.21. What is the ratio of the Unemployed and educated labor force (% of population) of High income in 2005 to that in 2011?
Offer a very short reply. 1.21. What is the ratio of the Unemployed and educated labor force (% of population) of Armenia in 2005 to that in 2011?
Keep it short and to the point. 0.52. What is the ratio of the Unemployed and educated labor force (% of population) of Bahrain in 2005 to that in 2011?
Ensure brevity in your answer.  1.35. What is the ratio of the Unemployed and educated labor force (% of population) of Panama in 2005 to that in 2011?
Offer a terse response. 0.61. What is the ratio of the Unemployed and educated labor force (% of population) of High income in 2005 to that in 2012?
Give a very brief answer. 1.31. What is the ratio of the Unemployed and educated labor force (% of population) in Armenia in 2005 to that in 2012?
Make the answer very short. 0.27. What is the ratio of the Unemployed and educated labor force (% of population) in Bahrain in 2005 to that in 2012?
Make the answer very short. 1.31. What is the ratio of the Unemployed and educated labor force (% of population) of Panama in 2005 to that in 2012?
Provide a short and direct response. 1.1. What is the ratio of the Unemployed and educated labor force (% of population) in High income in 2006 to that in 2007?
Keep it short and to the point. 0.96. What is the ratio of the Unemployed and educated labor force (% of population) in Armenia in 2006 to that in 2007?
Give a very brief answer. 0.69. What is the ratio of the Unemployed and educated labor force (% of population) of Bahrain in 2006 to that in 2007?
Keep it short and to the point. 1.12. What is the ratio of the Unemployed and educated labor force (% of population) of Panama in 2006 to that in 2007?
Provide a succinct answer. 1.1. What is the ratio of the Unemployed and educated labor force (% of population) in High income in 2006 to that in 2010?
Give a very brief answer. 1.27. What is the ratio of the Unemployed and educated labor force (% of population) of Armenia in 2006 to that in 2010?
Provide a short and direct response. 0.62. What is the ratio of the Unemployed and educated labor force (% of population) of Bahrain in 2006 to that in 2010?
Give a very brief answer. 1.69. What is the ratio of the Unemployed and educated labor force (% of population) in Panama in 2006 to that in 2010?
Your answer should be compact. 1.1. What is the ratio of the Unemployed and educated labor force (% of population) in High income in 2006 to that in 2011?
Make the answer very short. 1.23. What is the ratio of the Unemployed and educated labor force (% of population) in Armenia in 2006 to that in 2011?
Ensure brevity in your answer.  0.54. What is the ratio of the Unemployed and educated labor force (% of population) in Bahrain in 2006 to that in 2011?
Ensure brevity in your answer.  1.81. What is the ratio of the Unemployed and educated labor force (% of population) of Panama in 2006 to that in 2011?
Provide a succinct answer. 0.55. What is the ratio of the Unemployed and educated labor force (% of population) of High income in 2006 to that in 2012?
Offer a terse response. 1.33. What is the ratio of the Unemployed and educated labor force (% of population) in Armenia in 2006 to that in 2012?
Offer a terse response. 0.28. What is the ratio of the Unemployed and educated labor force (% of population) of Bahrain in 2006 to that in 2012?
Your answer should be very brief. 1.75. What is the ratio of the Unemployed and educated labor force (% of population) of Panama in 2006 to that in 2012?
Your answer should be very brief. 0.99. What is the ratio of the Unemployed and educated labor force (% of population) of High income in 2007 to that in 2010?
Offer a terse response. 1.32. What is the ratio of the Unemployed and educated labor force (% of population) of Armenia in 2007 to that in 2010?
Provide a short and direct response. 0.9. What is the ratio of the Unemployed and educated labor force (% of population) of Bahrain in 2007 to that in 2010?
Your response must be concise. 1.52. What is the ratio of the Unemployed and educated labor force (% of population) in Panama in 2007 to that in 2010?
Give a very brief answer. 1. What is the ratio of the Unemployed and educated labor force (% of population) in High income in 2007 to that in 2011?
Your response must be concise. 1.28. What is the ratio of the Unemployed and educated labor force (% of population) of Armenia in 2007 to that in 2011?
Your answer should be compact. 0.78. What is the ratio of the Unemployed and educated labor force (% of population) of Bahrain in 2007 to that in 2011?
Ensure brevity in your answer.  1.62. What is the ratio of the Unemployed and educated labor force (% of population) in Panama in 2007 to that in 2011?
Offer a terse response. 0.51. What is the ratio of the Unemployed and educated labor force (% of population) in High income in 2007 to that in 2012?
Offer a very short reply. 1.38. What is the ratio of the Unemployed and educated labor force (% of population) of Armenia in 2007 to that in 2012?
Offer a very short reply. 0.4. What is the ratio of the Unemployed and educated labor force (% of population) in Bahrain in 2007 to that in 2012?
Your response must be concise. 1.57. What is the ratio of the Unemployed and educated labor force (% of population) in Panama in 2007 to that in 2012?
Give a very brief answer. 0.91. What is the ratio of the Unemployed and educated labor force (% of population) in High income in 2010 to that in 2011?
Keep it short and to the point. 0.97. What is the ratio of the Unemployed and educated labor force (% of population) in Armenia in 2010 to that in 2011?
Offer a terse response. 0.87. What is the ratio of the Unemployed and educated labor force (% of population) in Bahrain in 2010 to that in 2011?
Your response must be concise. 1.07. What is the ratio of the Unemployed and educated labor force (% of population) of Panama in 2010 to that in 2011?
Give a very brief answer. 0.51. What is the ratio of the Unemployed and educated labor force (% of population) in High income in 2010 to that in 2012?
Provide a succinct answer. 1.04. What is the ratio of the Unemployed and educated labor force (% of population) of Armenia in 2010 to that in 2012?
Keep it short and to the point. 0.45. What is the ratio of the Unemployed and educated labor force (% of population) in Bahrain in 2010 to that in 2012?
Your answer should be very brief. 1.03. What is the ratio of the Unemployed and educated labor force (% of population) in Panama in 2010 to that in 2012?
Give a very brief answer. 0.91. What is the ratio of the Unemployed and educated labor force (% of population) in High income in 2011 to that in 2012?
Offer a very short reply. 1.08. What is the ratio of the Unemployed and educated labor force (% of population) in Armenia in 2011 to that in 2012?
Provide a short and direct response. 0.52. What is the ratio of the Unemployed and educated labor force (% of population) of Bahrain in 2011 to that in 2012?
Provide a succinct answer. 0.97. What is the ratio of the Unemployed and educated labor force (% of population) of Panama in 2011 to that in 2012?
Give a very brief answer. 1.79. What is the difference between the highest and the second highest Unemployed and educated labor force (% of population) of High income?
Your answer should be compact. 1.02. What is the difference between the highest and the second highest Unemployed and educated labor force (% of population) in Armenia?
Your answer should be very brief. 25. What is the difference between the highest and the second highest Unemployed and educated labor force (% of population) in Panama?
Provide a short and direct response. 18.3. What is the difference between the highest and the lowest Unemployed and educated labor force (% of population) in High income?
Give a very brief answer. 7.14. What is the difference between the highest and the lowest Unemployed and educated labor force (% of population) in Armenia?
Your answer should be compact. 38.6. What is the difference between the highest and the lowest Unemployed and educated labor force (% of population) in Bahrain?
Make the answer very short. 15.8. What is the difference between the highest and the lowest Unemployed and educated labor force (% of population) in Panama?
Your answer should be very brief. 23.4. 